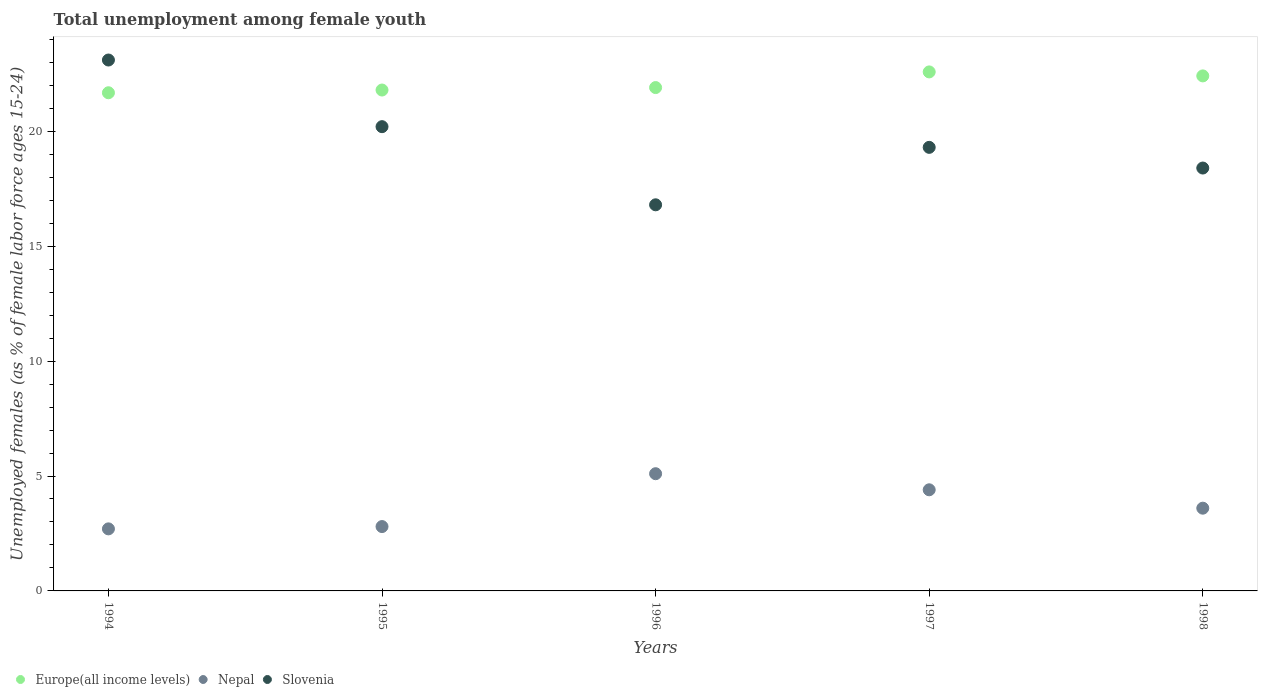How many different coloured dotlines are there?
Your response must be concise. 3. What is the percentage of unemployed females in in Slovenia in 1996?
Your answer should be very brief. 16.8. Across all years, what is the maximum percentage of unemployed females in in Slovenia?
Your answer should be compact. 23.1. Across all years, what is the minimum percentage of unemployed females in in Slovenia?
Offer a very short reply. 16.8. What is the total percentage of unemployed females in in Slovenia in the graph?
Offer a very short reply. 97.8. What is the difference between the percentage of unemployed females in in Europe(all income levels) in 1997 and that in 1998?
Offer a very short reply. 0.17. What is the difference between the percentage of unemployed females in in Europe(all income levels) in 1997 and the percentage of unemployed females in in Nepal in 1995?
Give a very brief answer. 19.78. What is the average percentage of unemployed females in in Nepal per year?
Keep it short and to the point. 3.72. In the year 1998, what is the difference between the percentage of unemployed females in in Nepal and percentage of unemployed females in in Europe(all income levels)?
Make the answer very short. -18.81. What is the ratio of the percentage of unemployed females in in Europe(all income levels) in 1996 to that in 1998?
Ensure brevity in your answer.  0.98. Is the percentage of unemployed females in in Nepal in 1995 less than that in 1998?
Your answer should be very brief. Yes. What is the difference between the highest and the second highest percentage of unemployed females in in Slovenia?
Provide a succinct answer. 2.9. What is the difference between the highest and the lowest percentage of unemployed females in in Nepal?
Offer a very short reply. 2.4. Is the sum of the percentage of unemployed females in in Europe(all income levels) in 1996 and 1997 greater than the maximum percentage of unemployed females in in Slovenia across all years?
Offer a terse response. Yes. Is the percentage of unemployed females in in Nepal strictly greater than the percentage of unemployed females in in Europe(all income levels) over the years?
Make the answer very short. No. How many dotlines are there?
Give a very brief answer. 3. How many years are there in the graph?
Your answer should be compact. 5. What is the difference between two consecutive major ticks on the Y-axis?
Your answer should be very brief. 5. Where does the legend appear in the graph?
Offer a terse response. Bottom left. How many legend labels are there?
Your answer should be compact. 3. How are the legend labels stacked?
Provide a succinct answer. Horizontal. What is the title of the graph?
Provide a succinct answer. Total unemployment among female youth. What is the label or title of the Y-axis?
Provide a short and direct response. Unemployed females (as % of female labor force ages 15-24). What is the Unemployed females (as % of female labor force ages 15-24) in Europe(all income levels) in 1994?
Make the answer very short. 21.68. What is the Unemployed females (as % of female labor force ages 15-24) of Nepal in 1994?
Provide a short and direct response. 2.7. What is the Unemployed females (as % of female labor force ages 15-24) of Slovenia in 1994?
Your answer should be very brief. 23.1. What is the Unemployed females (as % of female labor force ages 15-24) of Europe(all income levels) in 1995?
Offer a very short reply. 21.79. What is the Unemployed females (as % of female labor force ages 15-24) of Nepal in 1995?
Your answer should be very brief. 2.8. What is the Unemployed females (as % of female labor force ages 15-24) of Slovenia in 1995?
Provide a succinct answer. 20.2. What is the Unemployed females (as % of female labor force ages 15-24) of Europe(all income levels) in 1996?
Offer a very short reply. 21.9. What is the Unemployed females (as % of female labor force ages 15-24) of Nepal in 1996?
Your answer should be very brief. 5.1. What is the Unemployed females (as % of female labor force ages 15-24) in Slovenia in 1996?
Keep it short and to the point. 16.8. What is the Unemployed females (as % of female labor force ages 15-24) of Europe(all income levels) in 1997?
Make the answer very short. 22.58. What is the Unemployed females (as % of female labor force ages 15-24) of Nepal in 1997?
Your response must be concise. 4.4. What is the Unemployed females (as % of female labor force ages 15-24) of Slovenia in 1997?
Offer a very short reply. 19.3. What is the Unemployed females (as % of female labor force ages 15-24) of Europe(all income levels) in 1998?
Keep it short and to the point. 22.41. What is the Unemployed females (as % of female labor force ages 15-24) in Nepal in 1998?
Your answer should be compact. 3.6. What is the Unemployed females (as % of female labor force ages 15-24) of Slovenia in 1998?
Give a very brief answer. 18.4. Across all years, what is the maximum Unemployed females (as % of female labor force ages 15-24) of Europe(all income levels)?
Give a very brief answer. 22.58. Across all years, what is the maximum Unemployed females (as % of female labor force ages 15-24) in Nepal?
Provide a succinct answer. 5.1. Across all years, what is the maximum Unemployed females (as % of female labor force ages 15-24) of Slovenia?
Your response must be concise. 23.1. Across all years, what is the minimum Unemployed females (as % of female labor force ages 15-24) of Europe(all income levels)?
Make the answer very short. 21.68. Across all years, what is the minimum Unemployed females (as % of female labor force ages 15-24) of Nepal?
Provide a succinct answer. 2.7. Across all years, what is the minimum Unemployed females (as % of female labor force ages 15-24) of Slovenia?
Your answer should be very brief. 16.8. What is the total Unemployed females (as % of female labor force ages 15-24) of Europe(all income levels) in the graph?
Give a very brief answer. 110.36. What is the total Unemployed females (as % of female labor force ages 15-24) in Nepal in the graph?
Offer a terse response. 18.6. What is the total Unemployed females (as % of female labor force ages 15-24) in Slovenia in the graph?
Keep it short and to the point. 97.8. What is the difference between the Unemployed females (as % of female labor force ages 15-24) of Europe(all income levels) in 1994 and that in 1995?
Give a very brief answer. -0.12. What is the difference between the Unemployed females (as % of female labor force ages 15-24) in Nepal in 1994 and that in 1995?
Provide a short and direct response. -0.1. What is the difference between the Unemployed females (as % of female labor force ages 15-24) in Slovenia in 1994 and that in 1995?
Keep it short and to the point. 2.9. What is the difference between the Unemployed females (as % of female labor force ages 15-24) of Europe(all income levels) in 1994 and that in 1996?
Offer a terse response. -0.23. What is the difference between the Unemployed females (as % of female labor force ages 15-24) in Slovenia in 1994 and that in 1996?
Make the answer very short. 6.3. What is the difference between the Unemployed females (as % of female labor force ages 15-24) in Europe(all income levels) in 1994 and that in 1997?
Provide a succinct answer. -0.91. What is the difference between the Unemployed females (as % of female labor force ages 15-24) in Nepal in 1994 and that in 1997?
Ensure brevity in your answer.  -1.7. What is the difference between the Unemployed females (as % of female labor force ages 15-24) of Slovenia in 1994 and that in 1997?
Offer a terse response. 3.8. What is the difference between the Unemployed females (as % of female labor force ages 15-24) of Europe(all income levels) in 1994 and that in 1998?
Keep it short and to the point. -0.73. What is the difference between the Unemployed females (as % of female labor force ages 15-24) in Slovenia in 1994 and that in 1998?
Offer a terse response. 4.7. What is the difference between the Unemployed females (as % of female labor force ages 15-24) in Europe(all income levels) in 1995 and that in 1996?
Your answer should be very brief. -0.11. What is the difference between the Unemployed females (as % of female labor force ages 15-24) in Nepal in 1995 and that in 1996?
Your answer should be compact. -2.3. What is the difference between the Unemployed females (as % of female labor force ages 15-24) in Slovenia in 1995 and that in 1996?
Offer a very short reply. 3.4. What is the difference between the Unemployed females (as % of female labor force ages 15-24) of Europe(all income levels) in 1995 and that in 1997?
Your answer should be very brief. -0.79. What is the difference between the Unemployed females (as % of female labor force ages 15-24) of Nepal in 1995 and that in 1997?
Provide a succinct answer. -1.6. What is the difference between the Unemployed females (as % of female labor force ages 15-24) of Europe(all income levels) in 1995 and that in 1998?
Offer a terse response. -0.61. What is the difference between the Unemployed females (as % of female labor force ages 15-24) of Nepal in 1995 and that in 1998?
Make the answer very short. -0.8. What is the difference between the Unemployed females (as % of female labor force ages 15-24) of Europe(all income levels) in 1996 and that in 1997?
Your answer should be compact. -0.68. What is the difference between the Unemployed females (as % of female labor force ages 15-24) of Europe(all income levels) in 1996 and that in 1998?
Offer a terse response. -0.51. What is the difference between the Unemployed females (as % of female labor force ages 15-24) in Nepal in 1996 and that in 1998?
Provide a short and direct response. 1.5. What is the difference between the Unemployed females (as % of female labor force ages 15-24) of Slovenia in 1996 and that in 1998?
Your answer should be very brief. -1.6. What is the difference between the Unemployed females (as % of female labor force ages 15-24) in Europe(all income levels) in 1997 and that in 1998?
Offer a terse response. 0.17. What is the difference between the Unemployed females (as % of female labor force ages 15-24) of Slovenia in 1997 and that in 1998?
Your response must be concise. 0.9. What is the difference between the Unemployed females (as % of female labor force ages 15-24) in Europe(all income levels) in 1994 and the Unemployed females (as % of female labor force ages 15-24) in Nepal in 1995?
Your response must be concise. 18.88. What is the difference between the Unemployed females (as % of female labor force ages 15-24) of Europe(all income levels) in 1994 and the Unemployed females (as % of female labor force ages 15-24) of Slovenia in 1995?
Offer a terse response. 1.48. What is the difference between the Unemployed females (as % of female labor force ages 15-24) of Nepal in 1994 and the Unemployed females (as % of female labor force ages 15-24) of Slovenia in 1995?
Provide a short and direct response. -17.5. What is the difference between the Unemployed females (as % of female labor force ages 15-24) of Europe(all income levels) in 1994 and the Unemployed females (as % of female labor force ages 15-24) of Nepal in 1996?
Provide a succinct answer. 16.58. What is the difference between the Unemployed females (as % of female labor force ages 15-24) in Europe(all income levels) in 1994 and the Unemployed females (as % of female labor force ages 15-24) in Slovenia in 1996?
Your answer should be very brief. 4.88. What is the difference between the Unemployed females (as % of female labor force ages 15-24) in Nepal in 1994 and the Unemployed females (as % of female labor force ages 15-24) in Slovenia in 1996?
Provide a succinct answer. -14.1. What is the difference between the Unemployed females (as % of female labor force ages 15-24) in Europe(all income levels) in 1994 and the Unemployed females (as % of female labor force ages 15-24) in Nepal in 1997?
Offer a very short reply. 17.28. What is the difference between the Unemployed females (as % of female labor force ages 15-24) of Europe(all income levels) in 1994 and the Unemployed females (as % of female labor force ages 15-24) of Slovenia in 1997?
Give a very brief answer. 2.38. What is the difference between the Unemployed females (as % of female labor force ages 15-24) in Nepal in 1994 and the Unemployed females (as % of female labor force ages 15-24) in Slovenia in 1997?
Make the answer very short. -16.6. What is the difference between the Unemployed females (as % of female labor force ages 15-24) of Europe(all income levels) in 1994 and the Unemployed females (as % of female labor force ages 15-24) of Nepal in 1998?
Provide a short and direct response. 18.08. What is the difference between the Unemployed females (as % of female labor force ages 15-24) of Europe(all income levels) in 1994 and the Unemployed females (as % of female labor force ages 15-24) of Slovenia in 1998?
Provide a succinct answer. 3.28. What is the difference between the Unemployed females (as % of female labor force ages 15-24) in Nepal in 1994 and the Unemployed females (as % of female labor force ages 15-24) in Slovenia in 1998?
Your answer should be compact. -15.7. What is the difference between the Unemployed females (as % of female labor force ages 15-24) in Europe(all income levels) in 1995 and the Unemployed females (as % of female labor force ages 15-24) in Nepal in 1996?
Make the answer very short. 16.69. What is the difference between the Unemployed females (as % of female labor force ages 15-24) in Europe(all income levels) in 1995 and the Unemployed females (as % of female labor force ages 15-24) in Slovenia in 1996?
Your answer should be very brief. 4.99. What is the difference between the Unemployed females (as % of female labor force ages 15-24) in Europe(all income levels) in 1995 and the Unemployed females (as % of female labor force ages 15-24) in Nepal in 1997?
Ensure brevity in your answer.  17.39. What is the difference between the Unemployed females (as % of female labor force ages 15-24) of Europe(all income levels) in 1995 and the Unemployed females (as % of female labor force ages 15-24) of Slovenia in 1997?
Keep it short and to the point. 2.49. What is the difference between the Unemployed females (as % of female labor force ages 15-24) in Nepal in 1995 and the Unemployed females (as % of female labor force ages 15-24) in Slovenia in 1997?
Provide a succinct answer. -16.5. What is the difference between the Unemployed females (as % of female labor force ages 15-24) in Europe(all income levels) in 1995 and the Unemployed females (as % of female labor force ages 15-24) in Nepal in 1998?
Your answer should be compact. 18.19. What is the difference between the Unemployed females (as % of female labor force ages 15-24) of Europe(all income levels) in 1995 and the Unemployed females (as % of female labor force ages 15-24) of Slovenia in 1998?
Your response must be concise. 3.39. What is the difference between the Unemployed females (as % of female labor force ages 15-24) in Nepal in 1995 and the Unemployed females (as % of female labor force ages 15-24) in Slovenia in 1998?
Provide a succinct answer. -15.6. What is the difference between the Unemployed females (as % of female labor force ages 15-24) of Europe(all income levels) in 1996 and the Unemployed females (as % of female labor force ages 15-24) of Nepal in 1997?
Your answer should be compact. 17.5. What is the difference between the Unemployed females (as % of female labor force ages 15-24) of Europe(all income levels) in 1996 and the Unemployed females (as % of female labor force ages 15-24) of Slovenia in 1997?
Provide a succinct answer. 2.6. What is the difference between the Unemployed females (as % of female labor force ages 15-24) of Nepal in 1996 and the Unemployed females (as % of female labor force ages 15-24) of Slovenia in 1997?
Provide a short and direct response. -14.2. What is the difference between the Unemployed females (as % of female labor force ages 15-24) of Europe(all income levels) in 1996 and the Unemployed females (as % of female labor force ages 15-24) of Nepal in 1998?
Ensure brevity in your answer.  18.3. What is the difference between the Unemployed females (as % of female labor force ages 15-24) in Europe(all income levels) in 1996 and the Unemployed females (as % of female labor force ages 15-24) in Slovenia in 1998?
Keep it short and to the point. 3.5. What is the difference between the Unemployed females (as % of female labor force ages 15-24) in Europe(all income levels) in 1997 and the Unemployed females (as % of female labor force ages 15-24) in Nepal in 1998?
Your response must be concise. 18.98. What is the difference between the Unemployed females (as % of female labor force ages 15-24) in Europe(all income levels) in 1997 and the Unemployed females (as % of female labor force ages 15-24) in Slovenia in 1998?
Give a very brief answer. 4.18. What is the difference between the Unemployed females (as % of female labor force ages 15-24) in Nepal in 1997 and the Unemployed females (as % of female labor force ages 15-24) in Slovenia in 1998?
Offer a terse response. -14. What is the average Unemployed females (as % of female labor force ages 15-24) in Europe(all income levels) per year?
Your response must be concise. 22.07. What is the average Unemployed females (as % of female labor force ages 15-24) in Nepal per year?
Your response must be concise. 3.72. What is the average Unemployed females (as % of female labor force ages 15-24) of Slovenia per year?
Your answer should be compact. 19.56. In the year 1994, what is the difference between the Unemployed females (as % of female labor force ages 15-24) of Europe(all income levels) and Unemployed females (as % of female labor force ages 15-24) of Nepal?
Your answer should be very brief. 18.98. In the year 1994, what is the difference between the Unemployed females (as % of female labor force ages 15-24) of Europe(all income levels) and Unemployed females (as % of female labor force ages 15-24) of Slovenia?
Provide a succinct answer. -1.42. In the year 1994, what is the difference between the Unemployed females (as % of female labor force ages 15-24) in Nepal and Unemployed females (as % of female labor force ages 15-24) in Slovenia?
Make the answer very short. -20.4. In the year 1995, what is the difference between the Unemployed females (as % of female labor force ages 15-24) in Europe(all income levels) and Unemployed females (as % of female labor force ages 15-24) in Nepal?
Ensure brevity in your answer.  18.99. In the year 1995, what is the difference between the Unemployed females (as % of female labor force ages 15-24) of Europe(all income levels) and Unemployed females (as % of female labor force ages 15-24) of Slovenia?
Provide a succinct answer. 1.59. In the year 1995, what is the difference between the Unemployed females (as % of female labor force ages 15-24) of Nepal and Unemployed females (as % of female labor force ages 15-24) of Slovenia?
Provide a short and direct response. -17.4. In the year 1996, what is the difference between the Unemployed females (as % of female labor force ages 15-24) of Europe(all income levels) and Unemployed females (as % of female labor force ages 15-24) of Nepal?
Provide a short and direct response. 16.8. In the year 1996, what is the difference between the Unemployed females (as % of female labor force ages 15-24) of Europe(all income levels) and Unemployed females (as % of female labor force ages 15-24) of Slovenia?
Your response must be concise. 5.1. In the year 1996, what is the difference between the Unemployed females (as % of female labor force ages 15-24) in Nepal and Unemployed females (as % of female labor force ages 15-24) in Slovenia?
Provide a short and direct response. -11.7. In the year 1997, what is the difference between the Unemployed females (as % of female labor force ages 15-24) in Europe(all income levels) and Unemployed females (as % of female labor force ages 15-24) in Nepal?
Give a very brief answer. 18.18. In the year 1997, what is the difference between the Unemployed females (as % of female labor force ages 15-24) in Europe(all income levels) and Unemployed females (as % of female labor force ages 15-24) in Slovenia?
Your answer should be very brief. 3.28. In the year 1997, what is the difference between the Unemployed females (as % of female labor force ages 15-24) of Nepal and Unemployed females (as % of female labor force ages 15-24) of Slovenia?
Provide a succinct answer. -14.9. In the year 1998, what is the difference between the Unemployed females (as % of female labor force ages 15-24) in Europe(all income levels) and Unemployed females (as % of female labor force ages 15-24) in Nepal?
Keep it short and to the point. 18.81. In the year 1998, what is the difference between the Unemployed females (as % of female labor force ages 15-24) of Europe(all income levels) and Unemployed females (as % of female labor force ages 15-24) of Slovenia?
Provide a succinct answer. 4.01. In the year 1998, what is the difference between the Unemployed females (as % of female labor force ages 15-24) of Nepal and Unemployed females (as % of female labor force ages 15-24) of Slovenia?
Give a very brief answer. -14.8. What is the ratio of the Unemployed females (as % of female labor force ages 15-24) of Nepal in 1994 to that in 1995?
Give a very brief answer. 0.96. What is the ratio of the Unemployed females (as % of female labor force ages 15-24) in Slovenia in 1994 to that in 1995?
Offer a terse response. 1.14. What is the ratio of the Unemployed females (as % of female labor force ages 15-24) in Nepal in 1994 to that in 1996?
Keep it short and to the point. 0.53. What is the ratio of the Unemployed females (as % of female labor force ages 15-24) in Slovenia in 1994 to that in 1996?
Make the answer very short. 1.38. What is the ratio of the Unemployed females (as % of female labor force ages 15-24) of Europe(all income levels) in 1994 to that in 1997?
Your response must be concise. 0.96. What is the ratio of the Unemployed females (as % of female labor force ages 15-24) of Nepal in 1994 to that in 1997?
Your answer should be very brief. 0.61. What is the ratio of the Unemployed females (as % of female labor force ages 15-24) of Slovenia in 1994 to that in 1997?
Make the answer very short. 1.2. What is the ratio of the Unemployed females (as % of female labor force ages 15-24) of Europe(all income levels) in 1994 to that in 1998?
Give a very brief answer. 0.97. What is the ratio of the Unemployed females (as % of female labor force ages 15-24) in Nepal in 1994 to that in 1998?
Your response must be concise. 0.75. What is the ratio of the Unemployed females (as % of female labor force ages 15-24) of Slovenia in 1994 to that in 1998?
Your answer should be very brief. 1.26. What is the ratio of the Unemployed females (as % of female labor force ages 15-24) in Nepal in 1995 to that in 1996?
Your response must be concise. 0.55. What is the ratio of the Unemployed females (as % of female labor force ages 15-24) in Slovenia in 1995 to that in 1996?
Make the answer very short. 1.2. What is the ratio of the Unemployed females (as % of female labor force ages 15-24) in Europe(all income levels) in 1995 to that in 1997?
Ensure brevity in your answer.  0.97. What is the ratio of the Unemployed females (as % of female labor force ages 15-24) of Nepal in 1995 to that in 1997?
Keep it short and to the point. 0.64. What is the ratio of the Unemployed females (as % of female labor force ages 15-24) of Slovenia in 1995 to that in 1997?
Your answer should be compact. 1.05. What is the ratio of the Unemployed females (as % of female labor force ages 15-24) in Europe(all income levels) in 1995 to that in 1998?
Your answer should be compact. 0.97. What is the ratio of the Unemployed females (as % of female labor force ages 15-24) of Nepal in 1995 to that in 1998?
Provide a succinct answer. 0.78. What is the ratio of the Unemployed females (as % of female labor force ages 15-24) of Slovenia in 1995 to that in 1998?
Offer a terse response. 1.1. What is the ratio of the Unemployed females (as % of female labor force ages 15-24) in Europe(all income levels) in 1996 to that in 1997?
Your response must be concise. 0.97. What is the ratio of the Unemployed females (as % of female labor force ages 15-24) of Nepal in 1996 to that in 1997?
Ensure brevity in your answer.  1.16. What is the ratio of the Unemployed females (as % of female labor force ages 15-24) in Slovenia in 1996 to that in 1997?
Your response must be concise. 0.87. What is the ratio of the Unemployed females (as % of female labor force ages 15-24) of Europe(all income levels) in 1996 to that in 1998?
Offer a terse response. 0.98. What is the ratio of the Unemployed females (as % of female labor force ages 15-24) in Nepal in 1996 to that in 1998?
Keep it short and to the point. 1.42. What is the ratio of the Unemployed females (as % of female labor force ages 15-24) of Europe(all income levels) in 1997 to that in 1998?
Provide a short and direct response. 1.01. What is the ratio of the Unemployed females (as % of female labor force ages 15-24) of Nepal in 1997 to that in 1998?
Make the answer very short. 1.22. What is the ratio of the Unemployed females (as % of female labor force ages 15-24) of Slovenia in 1997 to that in 1998?
Provide a short and direct response. 1.05. What is the difference between the highest and the second highest Unemployed females (as % of female labor force ages 15-24) in Europe(all income levels)?
Keep it short and to the point. 0.17. What is the difference between the highest and the second highest Unemployed females (as % of female labor force ages 15-24) in Nepal?
Provide a succinct answer. 0.7. What is the difference between the highest and the second highest Unemployed females (as % of female labor force ages 15-24) in Slovenia?
Keep it short and to the point. 2.9. What is the difference between the highest and the lowest Unemployed females (as % of female labor force ages 15-24) of Europe(all income levels)?
Provide a succinct answer. 0.91. What is the difference between the highest and the lowest Unemployed females (as % of female labor force ages 15-24) of Slovenia?
Offer a terse response. 6.3. 